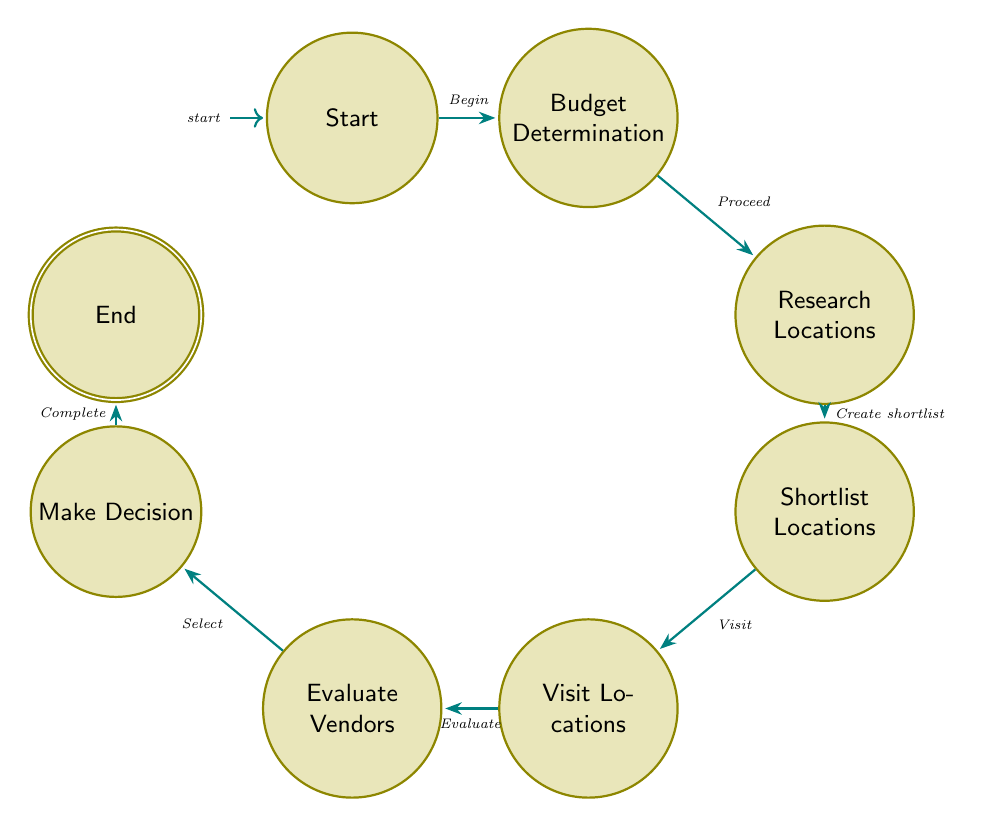What is the first state in the process? The first state is labeled "Start," which indicates the beginning of the wedding venue selection process.
Answer: Start How many states are in the diagram? There are eight distinct states represented in the diagram, from "Start" to "End."
Answer: Eight Which state follows after "Budget Determination"? The state that follows "Budget Determination" is "Research Locations," as indicated by the transition from the budget determination to the research stage.
Answer: Research Locations What is the last state in the selection process? The last state is labeled "End," signifying the completion of the wedding venue selection process.
Answer: End What action is taken after creating a shortlist of locations? After creating a shortlist of locations, the next action is to "Visit Locations," which involves inspecting the shortlisted venues.
Answer: Visit Locations What is the relationship between "Visit Locations" and "Evaluate Vendors"? "Visit Locations" precedes "Evaluate Vendors"; visitors evaluate the vendors associated with each venue after visiting.
Answer: Precedes How many transitions are there from “Research Locations” to “Make Decision”? There are four transitions from "Research Locations" to "Make Decision," connecting the respective states through the process until the final selection is made.
Answer: Four What occurs immediately after "Make Decision"? Immediately following "Make Decision" is the state "End," indicating that the selection process is complete and finalized.
Answer: End Which state evaluates vendors? The state responsible for evaluating vendors is labeled "Evaluate Vendors," where assessments of vendors linked to preferred venues are made.
Answer: Evaluate Vendors Is there a direct transition from "Research Locations" to "Evaluate Vendors"? No, there is no direct transition from "Research Locations" to "Evaluate Vendors"; rather, the flow goes through several states before reaching the vendor evaluation stage.
Answer: No 